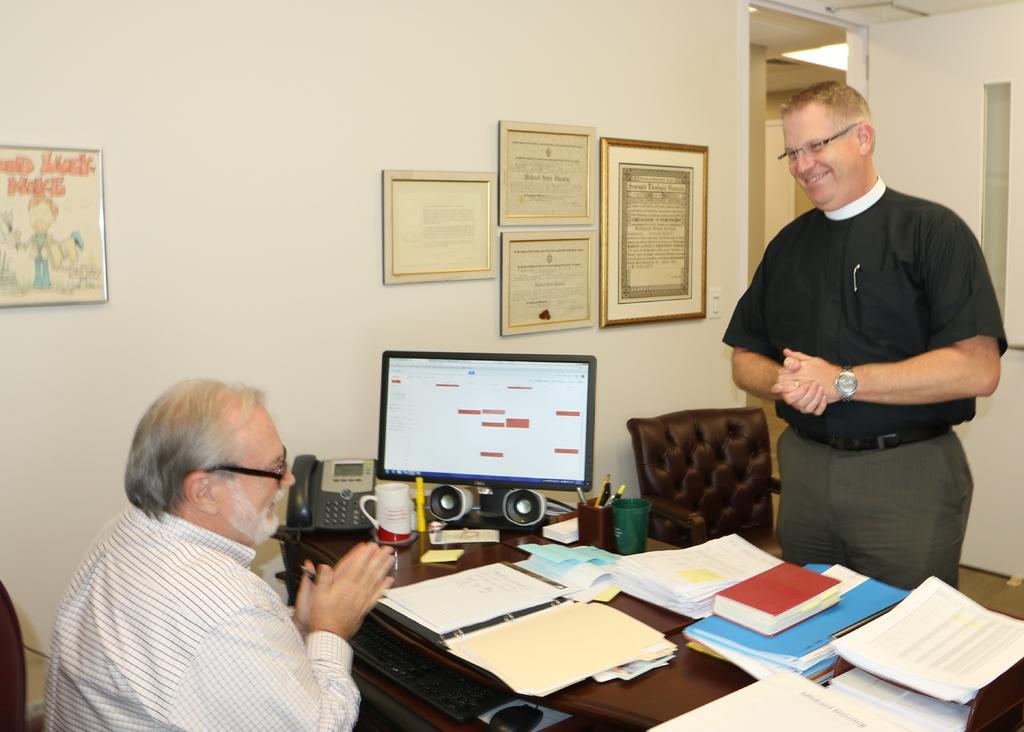How would you summarize this image in a sentence or two? In this image there is a man sitting, he is holding an object, there is a man standing, there is a table, there are objects on the table, there is a monitor, there is a chair, there is a wall, there are photo frames on the wall, there is roof towards the top of the image, there is a light, there is a door towards the right of the image, there is an object towards the left of the image. 